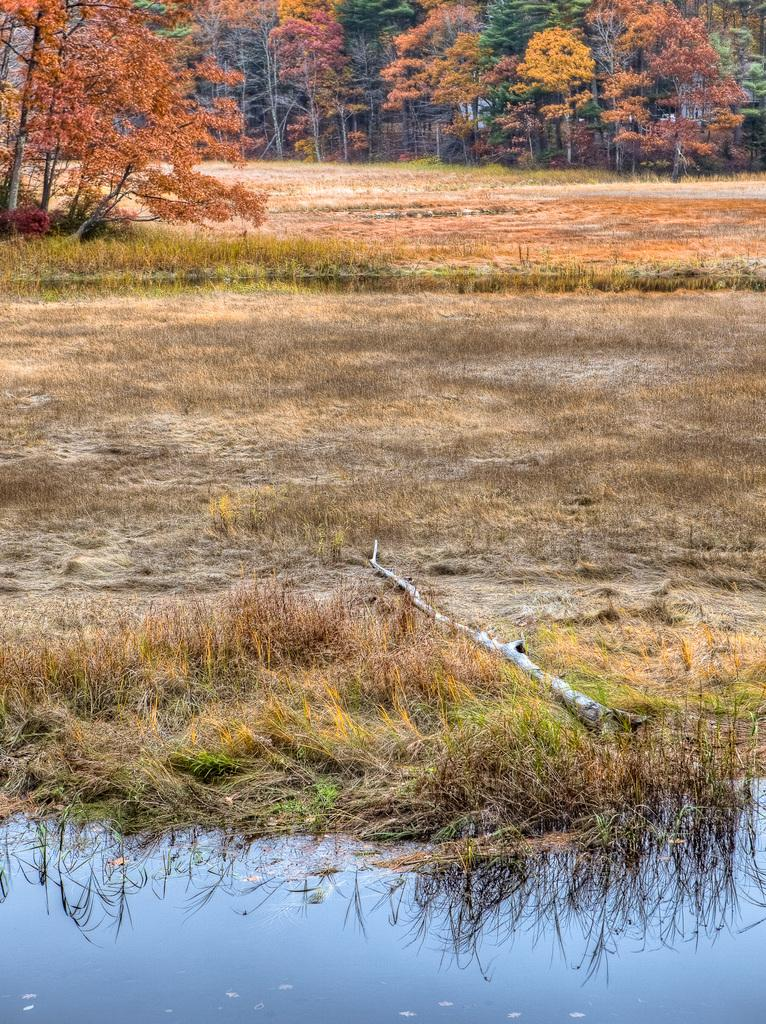What is at the bottom of the image? There is water at the bottom of the image. What can be seen in the distance in the image? There are trees in the background of the image. What type of vegetation is present in the background of the image? Dry grass is present in the background of the image. What is located in the foreground of the image? There is tree bark in the foreground of the image. What type of maid is depicted in the image? There is no maid present in the image; it features water, trees, dry grass, and tree bark. What country is the image taken in? The provided facts do not mention the country where the image was taken. 